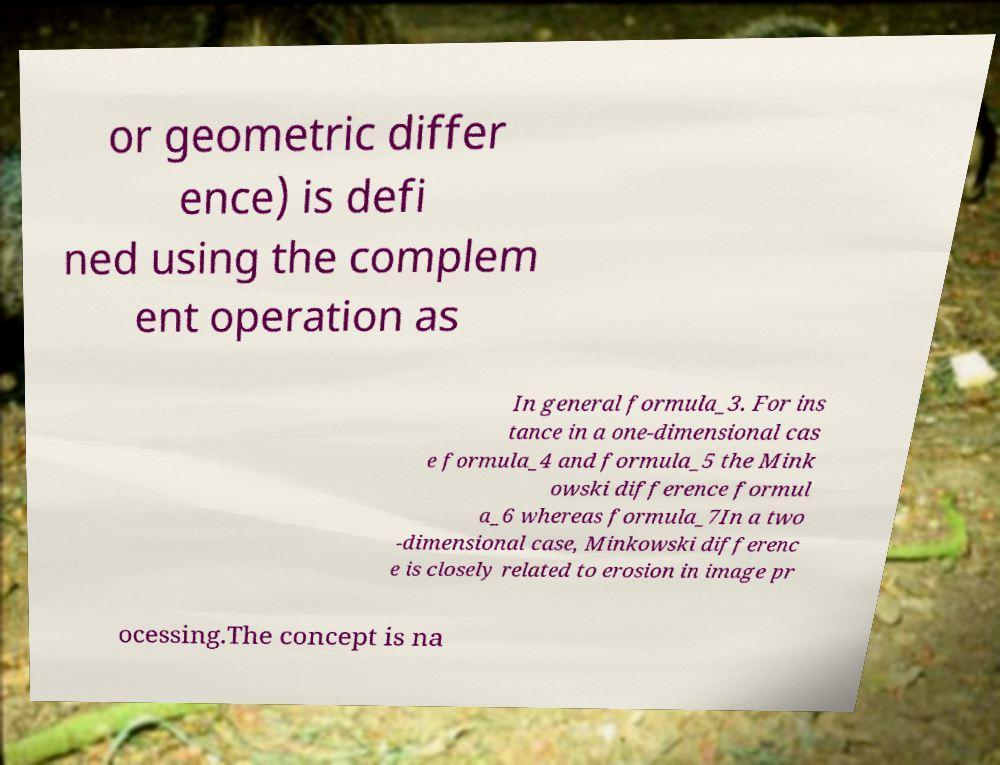I need the written content from this picture converted into text. Can you do that? or geometric differ ence) is defi ned using the complem ent operation as In general formula_3. For ins tance in a one-dimensional cas e formula_4 and formula_5 the Mink owski difference formul a_6 whereas formula_7In a two -dimensional case, Minkowski differenc e is closely related to erosion in image pr ocessing.The concept is na 